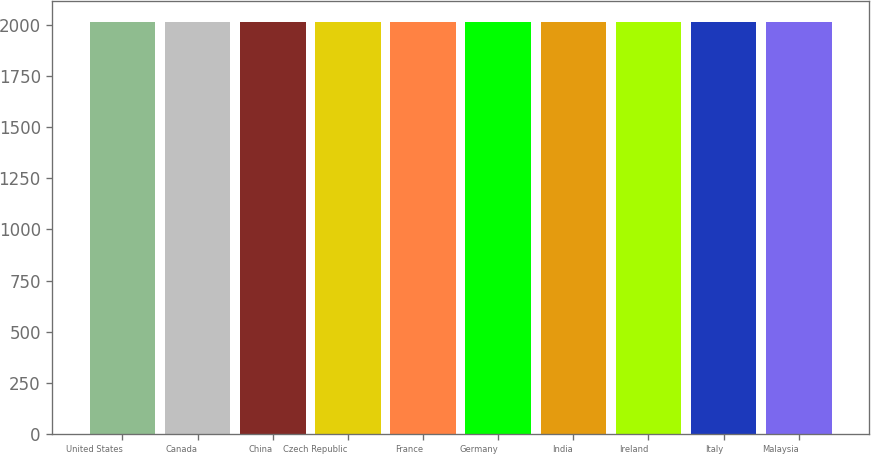<chart> <loc_0><loc_0><loc_500><loc_500><bar_chart><fcel>United States<fcel>Canada<fcel>China<fcel>Czech Republic<fcel>France<fcel>Germany<fcel>India<fcel>Ireland<fcel>Italy<fcel>Malaysia<nl><fcel>2015<fcel>2015.1<fcel>2015.2<fcel>2015.3<fcel>2015.4<fcel>2015.5<fcel>2015.6<fcel>2015.7<fcel>2015.8<fcel>2015.9<nl></chart> 